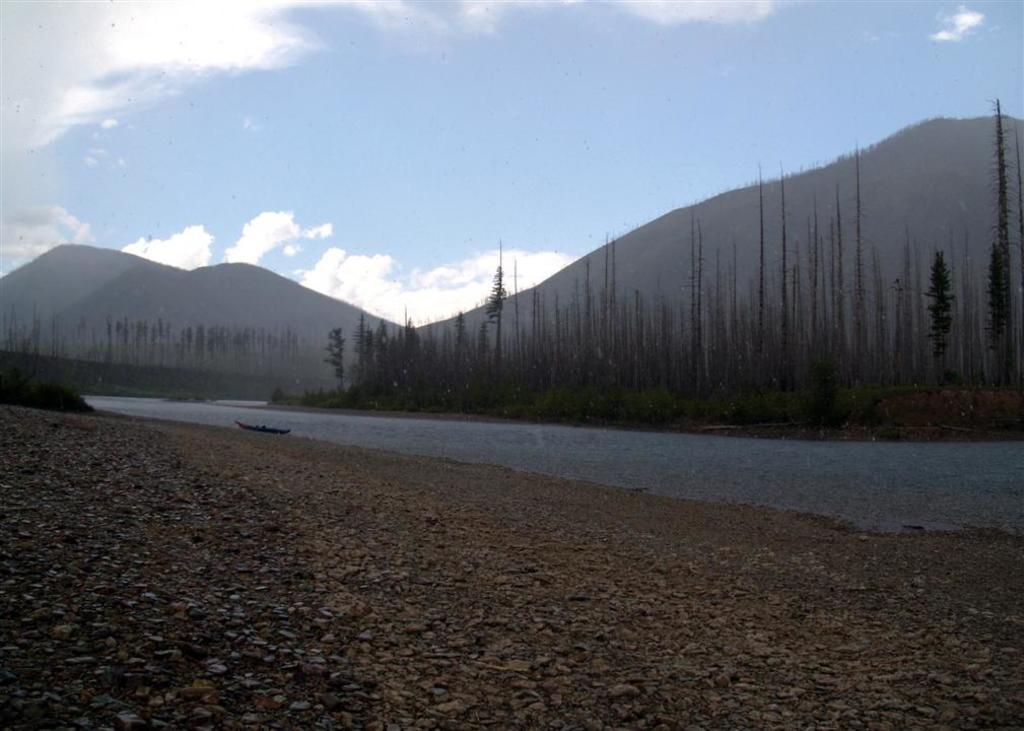How would you summarize this image in a sentence or two? In the image I can see a boat on the water. In the background I can see trees, mountains and the sky. 